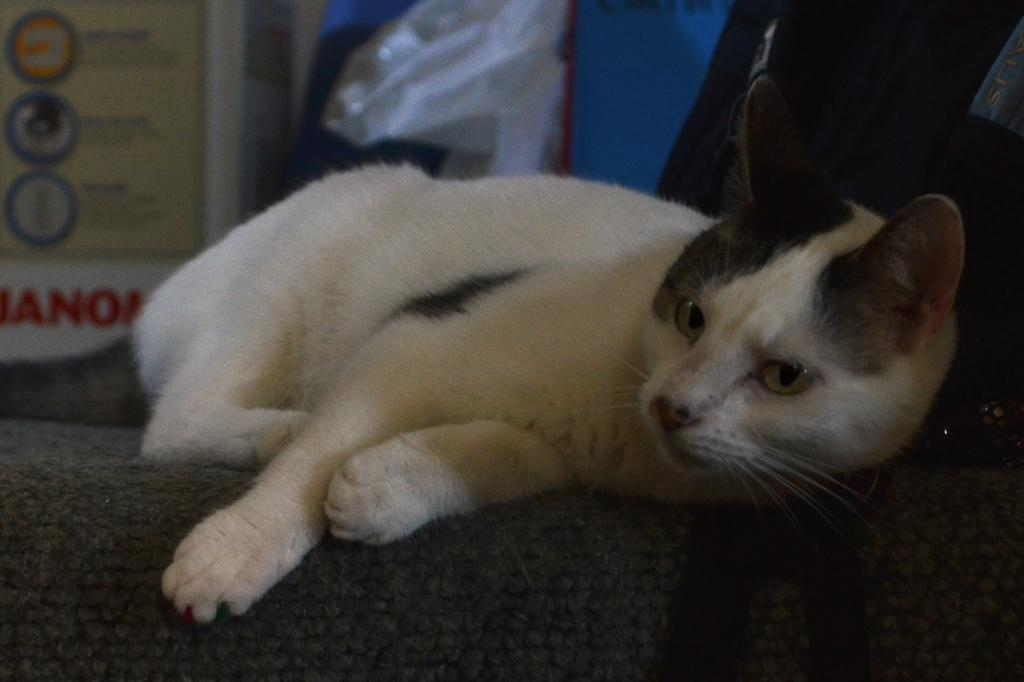What animal is lying on a mat in the image? There is a cat lying on a mat in the image. Where is the cat positioned in the image? The cat is in the middle of the image. What can be seen in the background of the image? There is a polythene cover and a chart in the background of the image. What color is the mat that the cat is lying on? The mat is black in color. What type of brass instrument is the cat playing in the image? There is no brass instrument present in the image; it features a cat lying on a mat. 